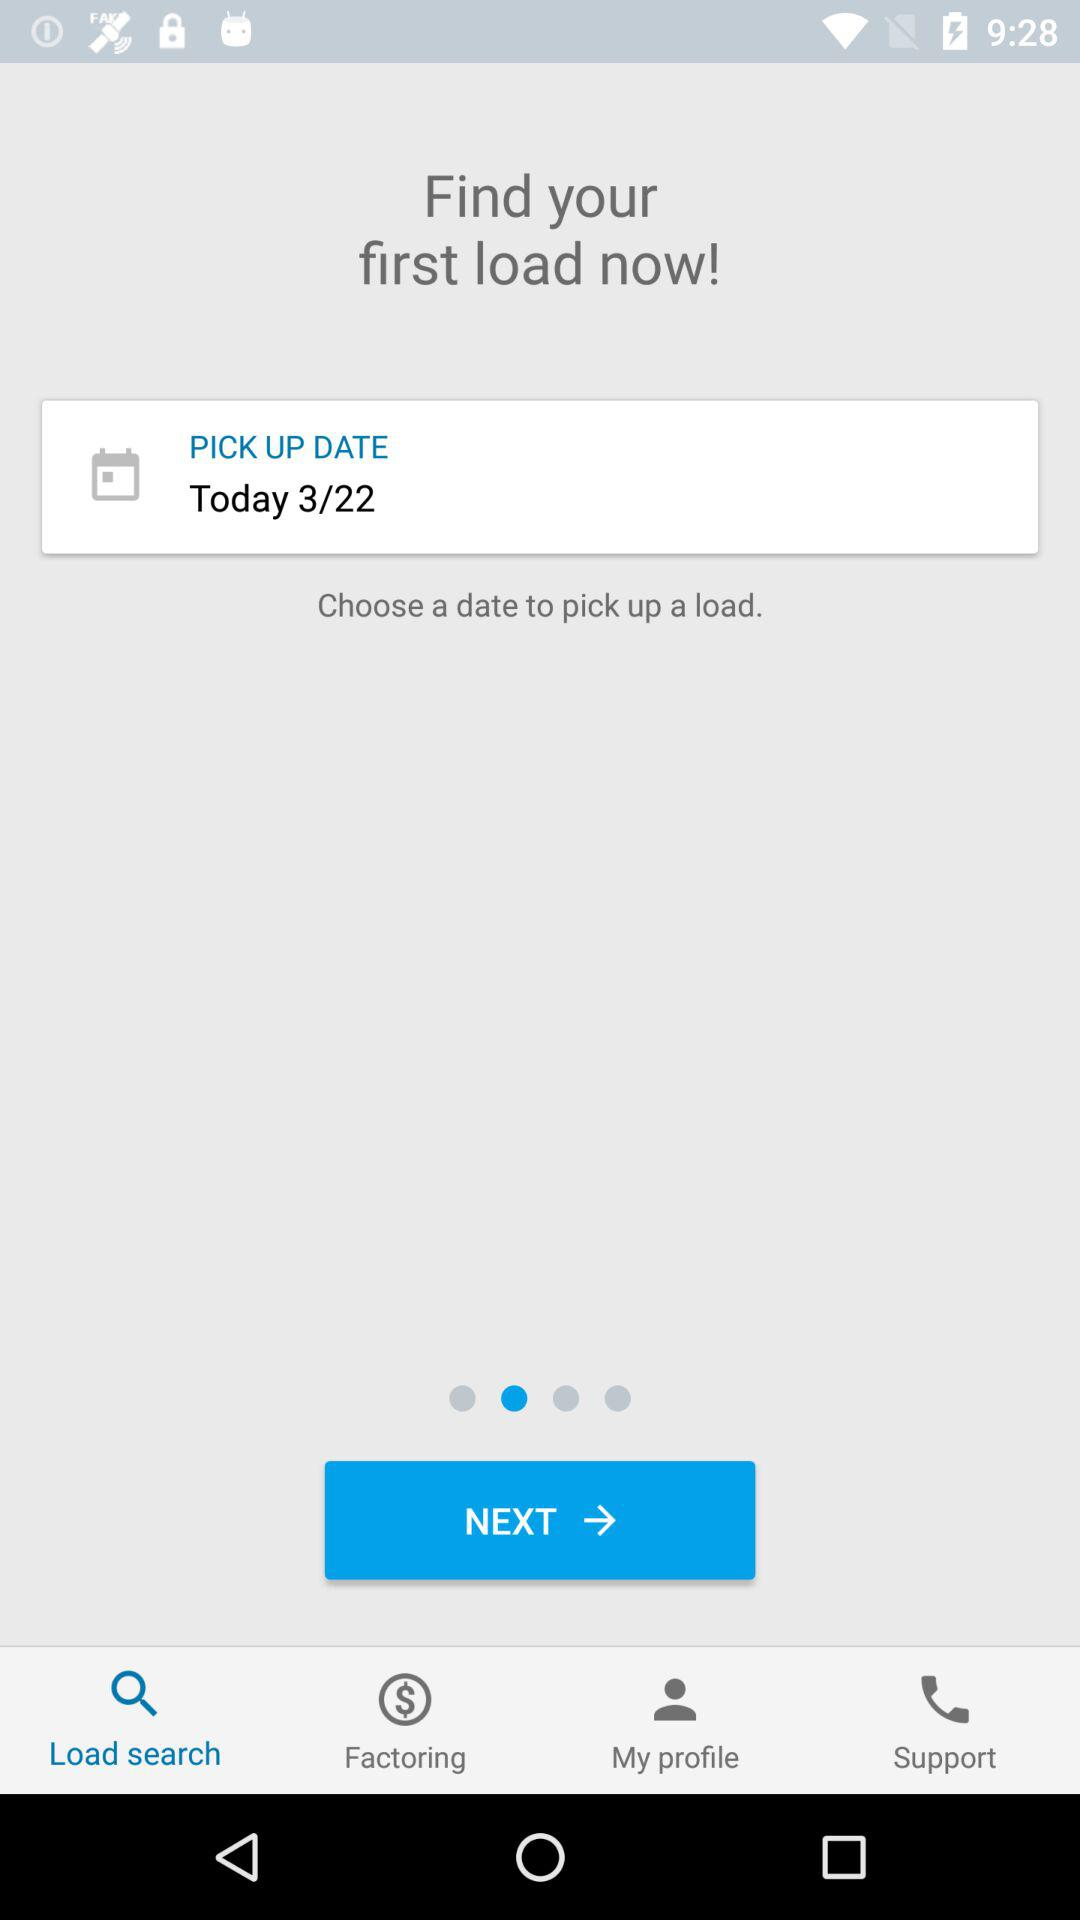What pickup date has been chosen? The chosen pickup date is March 22. 